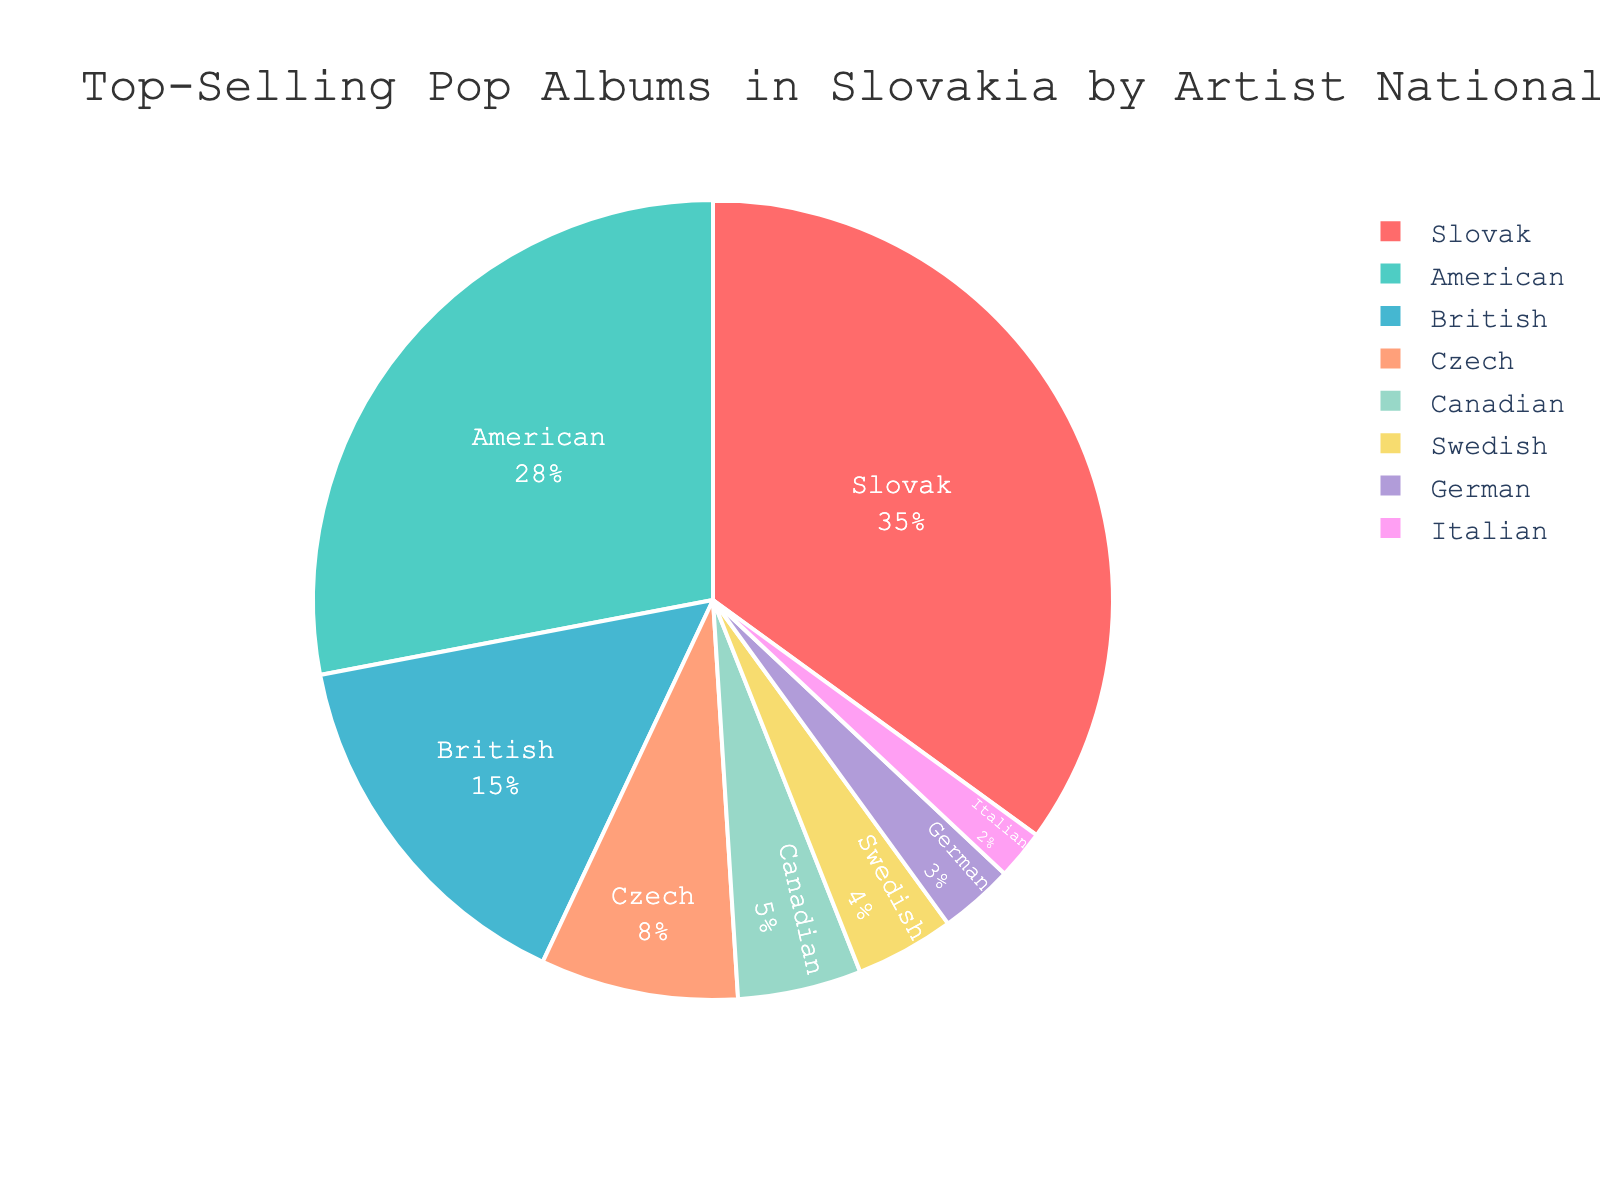Which artist nationality has the highest percentage of top-selling pop albums in Slovakia? The figure shows that the 'Slovak' artist nationality occupies the largest portion of the pie chart.
Answer: Slovak Which two artist nationalities combined account for over half of the top-selling pop albums? To find the combined percentage, add the percentages of the top two slices. Slovak (35%) + American (28%) = 63%, which is over half.
Answer: Slovak and American How much more percentage do Slovak artists have compared to British artists? Subtract the percentage of British artists from Slovak artists: 35% - 15% = 20%.
Answer: 20% What is the combined percentage of Canadian, Swedish, German, and Italian artists? Sum the percentages of the Canadian, Swedish, German, and Italian artists: 5% + 4% + 3% + 2% = 14%.
Answer: 14% Which artist nationality has the smallest percentage of top-selling pop albums? The figure shows that the 'Italian' artist nationality has the smallest slice in the pie chart.
Answer: Italian How does the percentage of American artists compare to the percentage of Czech artists? The percentage of American artists (28%) is more than three times the percentage of Czech artists (8%).
Answer: More than three times What portion of the pie chart is represented by Slovak and Czech artists combined? Add the percentages of Slovak and Czech artists: 35% + 8% = 43%.
Answer: 43% What percentage of top-selling pop albums are by artists not from Slovakia or America? Subtract the combined percentage of Slovak and American artists from 100%: 100% - (35% + 28%) = 37%.
Answer: 37% How many artist nationalities make up less than 10% of the top-selling pop albums each? Count the slices with percentages less than 10%: British (15%), Czech (8%), Canadian (5%), Swedish (4%), German (3%), and Italian (2%) add up to six nationalities.
Answer: 6 